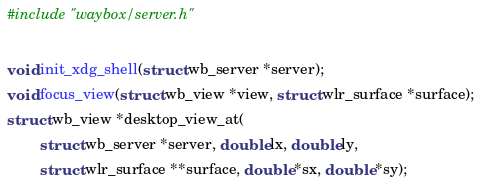<code> <loc_0><loc_0><loc_500><loc_500><_C_>#include "waybox/server.h"

void init_xdg_shell(struct wb_server *server);
void focus_view(struct wb_view *view, struct wlr_surface *surface);
struct wb_view *desktop_view_at(
		struct wb_server *server, double lx, double ly,
		struct wlr_surface **surface, double *sx, double *sy);
</code> 